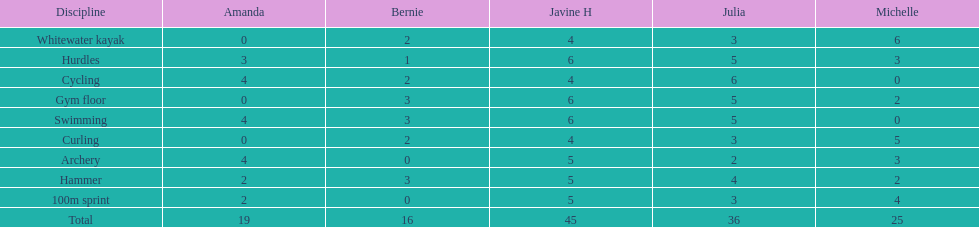What are the number of points bernie scored in hurdles? 1. 